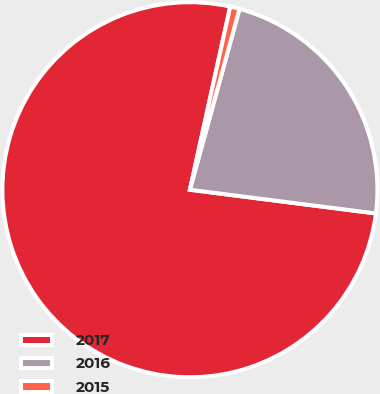<chart> <loc_0><loc_0><loc_500><loc_500><pie_chart><fcel>2017<fcel>2016<fcel>2015<nl><fcel>76.42%<fcel>22.76%<fcel>0.81%<nl></chart> 